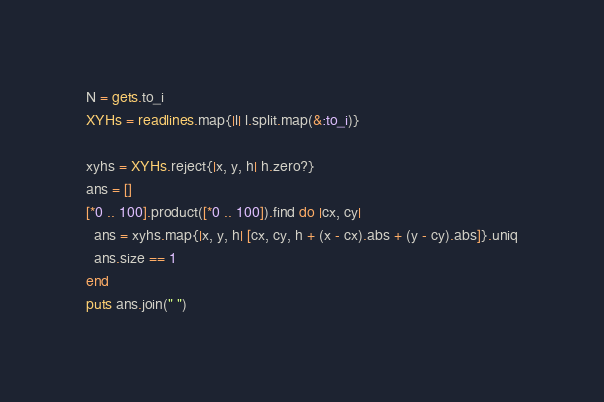<code> <loc_0><loc_0><loc_500><loc_500><_Ruby_>N = gets.to_i
XYHs = readlines.map{|l| l.split.map(&:to_i)}

xyhs = XYHs.reject{|x, y, h| h.zero?}
ans = []
[*0 .. 100].product([*0 .. 100]).find do |cx, cy|
  ans = xyhs.map{|x, y, h| [cx, cy, h + (x - cx).abs + (y - cy).abs]}.uniq
  ans.size == 1
end
puts ans.join(" ")</code> 